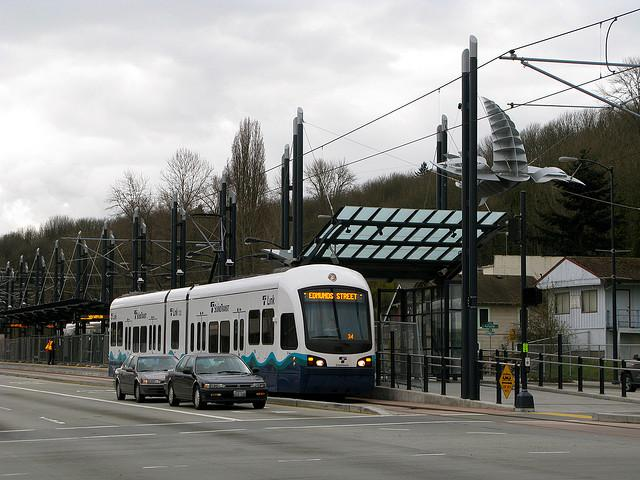What are white lines on road called?

Choices:
A) edge mark
B) border line
C) traffic line
D) cutting line border line 